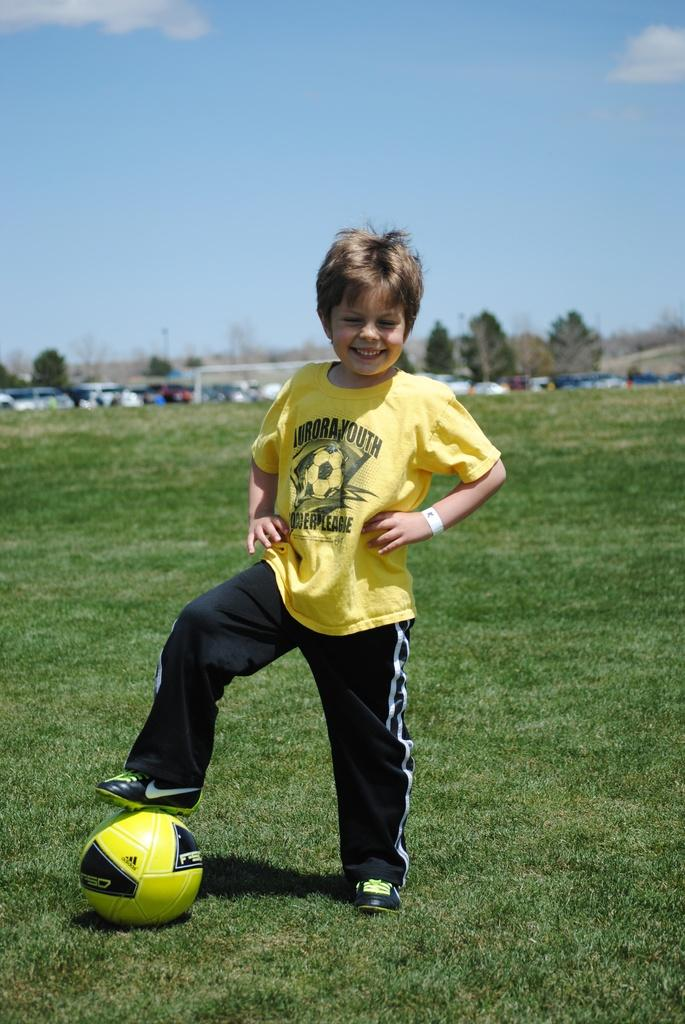<image>
Render a clear and concise summary of the photo. The yellow shirt says Aurora Youth Soccer League 